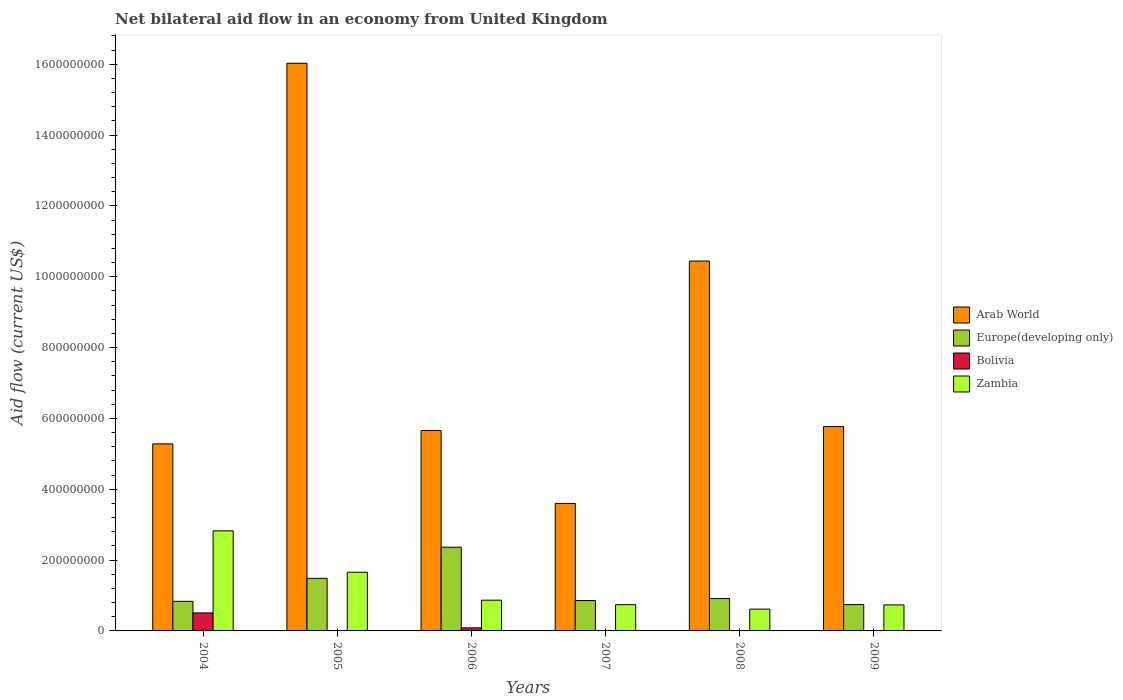How many different coloured bars are there?
Provide a succinct answer. 4. Are the number of bars per tick equal to the number of legend labels?
Ensure brevity in your answer.  No. Are the number of bars on each tick of the X-axis equal?
Give a very brief answer. No. What is the label of the 6th group of bars from the left?
Your answer should be very brief. 2009. In how many cases, is the number of bars for a given year not equal to the number of legend labels?
Ensure brevity in your answer.  2. What is the net bilateral aid flow in Arab World in 2005?
Your answer should be very brief. 1.60e+09. Across all years, what is the maximum net bilateral aid flow in Arab World?
Ensure brevity in your answer.  1.60e+09. Across all years, what is the minimum net bilateral aid flow in Europe(developing only)?
Make the answer very short. 7.44e+07. In which year was the net bilateral aid flow in Europe(developing only) maximum?
Your answer should be compact. 2006. What is the total net bilateral aid flow in Bolivia in the graph?
Offer a terse response. 6.11e+07. What is the difference between the net bilateral aid flow in Zambia in 2005 and that in 2007?
Give a very brief answer. 9.17e+07. What is the difference between the net bilateral aid flow in Europe(developing only) in 2007 and the net bilateral aid flow in Bolivia in 2005?
Your answer should be compact. 8.58e+07. What is the average net bilateral aid flow in Europe(developing only) per year?
Your response must be concise. 1.20e+08. In the year 2006, what is the difference between the net bilateral aid flow in Arab World and net bilateral aid flow in Europe(developing only)?
Offer a terse response. 3.30e+08. In how many years, is the net bilateral aid flow in Arab World greater than 80000000 US$?
Keep it short and to the point. 6. What is the ratio of the net bilateral aid flow in Europe(developing only) in 2005 to that in 2006?
Offer a terse response. 0.63. Is the net bilateral aid flow in Arab World in 2006 less than that in 2007?
Ensure brevity in your answer.  No. What is the difference between the highest and the second highest net bilateral aid flow in Zambia?
Provide a short and direct response. 1.17e+08. What is the difference between the highest and the lowest net bilateral aid flow in Arab World?
Offer a terse response. 1.24e+09. How many bars are there?
Provide a succinct answer. 22. Are the values on the major ticks of Y-axis written in scientific E-notation?
Offer a terse response. No. Does the graph contain any zero values?
Your answer should be very brief. Yes. Where does the legend appear in the graph?
Your response must be concise. Center right. What is the title of the graph?
Your answer should be very brief. Net bilateral aid flow in an economy from United Kingdom. What is the label or title of the X-axis?
Ensure brevity in your answer.  Years. What is the label or title of the Y-axis?
Your answer should be compact. Aid flow (current US$). What is the Aid flow (current US$) in Arab World in 2004?
Offer a very short reply. 5.28e+08. What is the Aid flow (current US$) of Europe(developing only) in 2004?
Offer a very short reply. 8.36e+07. What is the Aid flow (current US$) in Bolivia in 2004?
Your answer should be very brief. 5.08e+07. What is the Aid flow (current US$) of Zambia in 2004?
Your response must be concise. 2.83e+08. What is the Aid flow (current US$) of Arab World in 2005?
Your response must be concise. 1.60e+09. What is the Aid flow (current US$) of Europe(developing only) in 2005?
Offer a very short reply. 1.48e+08. What is the Aid flow (current US$) of Bolivia in 2005?
Ensure brevity in your answer.  0. What is the Aid flow (current US$) in Zambia in 2005?
Your answer should be very brief. 1.66e+08. What is the Aid flow (current US$) in Arab World in 2006?
Offer a terse response. 5.66e+08. What is the Aid flow (current US$) of Europe(developing only) in 2006?
Give a very brief answer. 2.36e+08. What is the Aid flow (current US$) in Bolivia in 2006?
Provide a short and direct response. 8.69e+06. What is the Aid flow (current US$) of Zambia in 2006?
Offer a very short reply. 8.68e+07. What is the Aid flow (current US$) of Arab World in 2007?
Your answer should be very brief. 3.60e+08. What is the Aid flow (current US$) of Europe(developing only) in 2007?
Your answer should be very brief. 8.58e+07. What is the Aid flow (current US$) in Bolivia in 2007?
Your answer should be very brief. 0. What is the Aid flow (current US$) of Zambia in 2007?
Make the answer very short. 7.40e+07. What is the Aid flow (current US$) of Arab World in 2008?
Make the answer very short. 1.04e+09. What is the Aid flow (current US$) in Europe(developing only) in 2008?
Keep it short and to the point. 9.15e+07. What is the Aid flow (current US$) of Bolivia in 2008?
Provide a short and direct response. 1.02e+06. What is the Aid flow (current US$) in Zambia in 2008?
Make the answer very short. 6.16e+07. What is the Aid flow (current US$) of Arab World in 2009?
Your answer should be compact. 5.77e+08. What is the Aid flow (current US$) of Europe(developing only) in 2009?
Ensure brevity in your answer.  7.44e+07. What is the Aid flow (current US$) of Bolivia in 2009?
Offer a terse response. 5.30e+05. What is the Aid flow (current US$) in Zambia in 2009?
Offer a very short reply. 7.35e+07. Across all years, what is the maximum Aid flow (current US$) in Arab World?
Provide a succinct answer. 1.60e+09. Across all years, what is the maximum Aid flow (current US$) in Europe(developing only)?
Offer a very short reply. 2.36e+08. Across all years, what is the maximum Aid flow (current US$) of Bolivia?
Offer a very short reply. 5.08e+07. Across all years, what is the maximum Aid flow (current US$) in Zambia?
Your response must be concise. 2.83e+08. Across all years, what is the minimum Aid flow (current US$) in Arab World?
Your answer should be compact. 3.60e+08. Across all years, what is the minimum Aid flow (current US$) of Europe(developing only)?
Offer a very short reply. 7.44e+07. Across all years, what is the minimum Aid flow (current US$) of Bolivia?
Your response must be concise. 0. Across all years, what is the minimum Aid flow (current US$) of Zambia?
Offer a terse response. 6.16e+07. What is the total Aid flow (current US$) of Arab World in the graph?
Ensure brevity in your answer.  4.68e+09. What is the total Aid flow (current US$) in Europe(developing only) in the graph?
Your answer should be compact. 7.20e+08. What is the total Aid flow (current US$) of Bolivia in the graph?
Keep it short and to the point. 6.11e+07. What is the total Aid flow (current US$) of Zambia in the graph?
Your answer should be compact. 7.44e+08. What is the difference between the Aid flow (current US$) in Arab World in 2004 and that in 2005?
Provide a succinct answer. -1.07e+09. What is the difference between the Aid flow (current US$) of Europe(developing only) in 2004 and that in 2005?
Make the answer very short. -6.49e+07. What is the difference between the Aid flow (current US$) of Zambia in 2004 and that in 2005?
Your answer should be very brief. 1.17e+08. What is the difference between the Aid flow (current US$) in Arab World in 2004 and that in 2006?
Your answer should be very brief. -3.78e+07. What is the difference between the Aid flow (current US$) in Europe(developing only) in 2004 and that in 2006?
Provide a succinct answer. -1.53e+08. What is the difference between the Aid flow (current US$) in Bolivia in 2004 and that in 2006?
Offer a terse response. 4.21e+07. What is the difference between the Aid flow (current US$) of Zambia in 2004 and that in 2006?
Keep it short and to the point. 1.96e+08. What is the difference between the Aid flow (current US$) in Arab World in 2004 and that in 2007?
Your response must be concise. 1.68e+08. What is the difference between the Aid flow (current US$) in Europe(developing only) in 2004 and that in 2007?
Provide a short and direct response. -2.20e+06. What is the difference between the Aid flow (current US$) in Zambia in 2004 and that in 2007?
Your answer should be very brief. 2.09e+08. What is the difference between the Aid flow (current US$) of Arab World in 2004 and that in 2008?
Your answer should be very brief. -5.16e+08. What is the difference between the Aid flow (current US$) of Europe(developing only) in 2004 and that in 2008?
Make the answer very short. -7.99e+06. What is the difference between the Aid flow (current US$) in Bolivia in 2004 and that in 2008?
Provide a short and direct response. 4.98e+07. What is the difference between the Aid flow (current US$) of Zambia in 2004 and that in 2008?
Your response must be concise. 2.21e+08. What is the difference between the Aid flow (current US$) in Arab World in 2004 and that in 2009?
Provide a short and direct response. -4.89e+07. What is the difference between the Aid flow (current US$) in Europe(developing only) in 2004 and that in 2009?
Give a very brief answer. 9.19e+06. What is the difference between the Aid flow (current US$) in Bolivia in 2004 and that in 2009?
Offer a very short reply. 5.03e+07. What is the difference between the Aid flow (current US$) of Zambia in 2004 and that in 2009?
Offer a terse response. 2.09e+08. What is the difference between the Aid flow (current US$) in Arab World in 2005 and that in 2006?
Your answer should be compact. 1.04e+09. What is the difference between the Aid flow (current US$) in Europe(developing only) in 2005 and that in 2006?
Keep it short and to the point. -8.79e+07. What is the difference between the Aid flow (current US$) in Zambia in 2005 and that in 2006?
Provide a short and direct response. 7.90e+07. What is the difference between the Aid flow (current US$) of Arab World in 2005 and that in 2007?
Provide a short and direct response. 1.24e+09. What is the difference between the Aid flow (current US$) in Europe(developing only) in 2005 and that in 2007?
Offer a terse response. 6.27e+07. What is the difference between the Aid flow (current US$) in Zambia in 2005 and that in 2007?
Provide a succinct answer. 9.17e+07. What is the difference between the Aid flow (current US$) of Arab World in 2005 and that in 2008?
Keep it short and to the point. 5.58e+08. What is the difference between the Aid flow (current US$) of Europe(developing only) in 2005 and that in 2008?
Provide a succinct answer. 5.69e+07. What is the difference between the Aid flow (current US$) of Zambia in 2005 and that in 2008?
Make the answer very short. 1.04e+08. What is the difference between the Aid flow (current US$) in Arab World in 2005 and that in 2009?
Ensure brevity in your answer.  1.03e+09. What is the difference between the Aid flow (current US$) in Europe(developing only) in 2005 and that in 2009?
Offer a very short reply. 7.41e+07. What is the difference between the Aid flow (current US$) in Zambia in 2005 and that in 2009?
Your response must be concise. 9.22e+07. What is the difference between the Aid flow (current US$) in Arab World in 2006 and that in 2007?
Keep it short and to the point. 2.06e+08. What is the difference between the Aid flow (current US$) of Europe(developing only) in 2006 and that in 2007?
Offer a terse response. 1.51e+08. What is the difference between the Aid flow (current US$) in Zambia in 2006 and that in 2007?
Ensure brevity in your answer.  1.28e+07. What is the difference between the Aid flow (current US$) of Arab World in 2006 and that in 2008?
Your answer should be compact. -4.78e+08. What is the difference between the Aid flow (current US$) in Europe(developing only) in 2006 and that in 2008?
Make the answer very short. 1.45e+08. What is the difference between the Aid flow (current US$) of Bolivia in 2006 and that in 2008?
Your answer should be compact. 7.67e+06. What is the difference between the Aid flow (current US$) of Zambia in 2006 and that in 2008?
Provide a succinct answer. 2.52e+07. What is the difference between the Aid flow (current US$) of Arab World in 2006 and that in 2009?
Offer a very short reply. -1.11e+07. What is the difference between the Aid flow (current US$) in Europe(developing only) in 2006 and that in 2009?
Your answer should be very brief. 1.62e+08. What is the difference between the Aid flow (current US$) in Bolivia in 2006 and that in 2009?
Your answer should be compact. 8.16e+06. What is the difference between the Aid flow (current US$) in Zambia in 2006 and that in 2009?
Give a very brief answer. 1.32e+07. What is the difference between the Aid flow (current US$) of Arab World in 2007 and that in 2008?
Your answer should be compact. -6.84e+08. What is the difference between the Aid flow (current US$) of Europe(developing only) in 2007 and that in 2008?
Ensure brevity in your answer.  -5.79e+06. What is the difference between the Aid flow (current US$) of Zambia in 2007 and that in 2008?
Offer a terse response. 1.25e+07. What is the difference between the Aid flow (current US$) of Arab World in 2007 and that in 2009?
Ensure brevity in your answer.  -2.17e+08. What is the difference between the Aid flow (current US$) of Europe(developing only) in 2007 and that in 2009?
Provide a short and direct response. 1.14e+07. What is the difference between the Aid flow (current US$) in Arab World in 2008 and that in 2009?
Provide a short and direct response. 4.67e+08. What is the difference between the Aid flow (current US$) of Europe(developing only) in 2008 and that in 2009?
Provide a succinct answer. 1.72e+07. What is the difference between the Aid flow (current US$) in Bolivia in 2008 and that in 2009?
Offer a terse response. 4.90e+05. What is the difference between the Aid flow (current US$) of Zambia in 2008 and that in 2009?
Give a very brief answer. -1.20e+07. What is the difference between the Aid flow (current US$) of Arab World in 2004 and the Aid flow (current US$) of Europe(developing only) in 2005?
Provide a succinct answer. 3.80e+08. What is the difference between the Aid flow (current US$) of Arab World in 2004 and the Aid flow (current US$) of Zambia in 2005?
Provide a short and direct response. 3.62e+08. What is the difference between the Aid flow (current US$) of Europe(developing only) in 2004 and the Aid flow (current US$) of Zambia in 2005?
Provide a succinct answer. -8.22e+07. What is the difference between the Aid flow (current US$) of Bolivia in 2004 and the Aid flow (current US$) of Zambia in 2005?
Ensure brevity in your answer.  -1.15e+08. What is the difference between the Aid flow (current US$) of Arab World in 2004 and the Aid flow (current US$) of Europe(developing only) in 2006?
Keep it short and to the point. 2.92e+08. What is the difference between the Aid flow (current US$) in Arab World in 2004 and the Aid flow (current US$) in Bolivia in 2006?
Give a very brief answer. 5.19e+08. What is the difference between the Aid flow (current US$) of Arab World in 2004 and the Aid flow (current US$) of Zambia in 2006?
Ensure brevity in your answer.  4.41e+08. What is the difference between the Aid flow (current US$) in Europe(developing only) in 2004 and the Aid flow (current US$) in Bolivia in 2006?
Offer a very short reply. 7.49e+07. What is the difference between the Aid flow (current US$) of Europe(developing only) in 2004 and the Aid flow (current US$) of Zambia in 2006?
Your response must be concise. -3.22e+06. What is the difference between the Aid flow (current US$) of Bolivia in 2004 and the Aid flow (current US$) of Zambia in 2006?
Offer a very short reply. -3.59e+07. What is the difference between the Aid flow (current US$) in Arab World in 2004 and the Aid flow (current US$) in Europe(developing only) in 2007?
Make the answer very short. 4.42e+08. What is the difference between the Aid flow (current US$) of Arab World in 2004 and the Aid flow (current US$) of Zambia in 2007?
Ensure brevity in your answer.  4.54e+08. What is the difference between the Aid flow (current US$) in Europe(developing only) in 2004 and the Aid flow (current US$) in Zambia in 2007?
Your answer should be compact. 9.53e+06. What is the difference between the Aid flow (current US$) in Bolivia in 2004 and the Aid flow (current US$) in Zambia in 2007?
Your response must be concise. -2.32e+07. What is the difference between the Aid flow (current US$) of Arab World in 2004 and the Aid flow (current US$) of Europe(developing only) in 2008?
Ensure brevity in your answer.  4.36e+08. What is the difference between the Aid flow (current US$) of Arab World in 2004 and the Aid flow (current US$) of Bolivia in 2008?
Keep it short and to the point. 5.27e+08. What is the difference between the Aid flow (current US$) of Arab World in 2004 and the Aid flow (current US$) of Zambia in 2008?
Ensure brevity in your answer.  4.66e+08. What is the difference between the Aid flow (current US$) in Europe(developing only) in 2004 and the Aid flow (current US$) in Bolivia in 2008?
Keep it short and to the point. 8.25e+07. What is the difference between the Aid flow (current US$) of Europe(developing only) in 2004 and the Aid flow (current US$) of Zambia in 2008?
Keep it short and to the point. 2.20e+07. What is the difference between the Aid flow (current US$) of Bolivia in 2004 and the Aid flow (current US$) of Zambia in 2008?
Provide a short and direct response. -1.07e+07. What is the difference between the Aid flow (current US$) of Arab World in 2004 and the Aid flow (current US$) of Europe(developing only) in 2009?
Give a very brief answer. 4.54e+08. What is the difference between the Aid flow (current US$) in Arab World in 2004 and the Aid flow (current US$) in Bolivia in 2009?
Your answer should be very brief. 5.27e+08. What is the difference between the Aid flow (current US$) of Arab World in 2004 and the Aid flow (current US$) of Zambia in 2009?
Provide a succinct answer. 4.54e+08. What is the difference between the Aid flow (current US$) of Europe(developing only) in 2004 and the Aid flow (current US$) of Bolivia in 2009?
Provide a succinct answer. 8.30e+07. What is the difference between the Aid flow (current US$) of Europe(developing only) in 2004 and the Aid flow (current US$) of Zambia in 2009?
Provide a short and direct response. 1.00e+07. What is the difference between the Aid flow (current US$) of Bolivia in 2004 and the Aid flow (current US$) of Zambia in 2009?
Your answer should be very brief. -2.27e+07. What is the difference between the Aid flow (current US$) of Arab World in 2005 and the Aid flow (current US$) of Europe(developing only) in 2006?
Offer a terse response. 1.37e+09. What is the difference between the Aid flow (current US$) in Arab World in 2005 and the Aid flow (current US$) in Bolivia in 2006?
Your answer should be compact. 1.59e+09. What is the difference between the Aid flow (current US$) of Arab World in 2005 and the Aid flow (current US$) of Zambia in 2006?
Offer a terse response. 1.52e+09. What is the difference between the Aid flow (current US$) of Europe(developing only) in 2005 and the Aid flow (current US$) of Bolivia in 2006?
Provide a short and direct response. 1.40e+08. What is the difference between the Aid flow (current US$) of Europe(developing only) in 2005 and the Aid flow (current US$) of Zambia in 2006?
Your answer should be compact. 6.17e+07. What is the difference between the Aid flow (current US$) of Arab World in 2005 and the Aid flow (current US$) of Europe(developing only) in 2007?
Offer a terse response. 1.52e+09. What is the difference between the Aid flow (current US$) in Arab World in 2005 and the Aid flow (current US$) in Zambia in 2007?
Keep it short and to the point. 1.53e+09. What is the difference between the Aid flow (current US$) of Europe(developing only) in 2005 and the Aid flow (current US$) of Zambia in 2007?
Provide a short and direct response. 7.44e+07. What is the difference between the Aid flow (current US$) in Arab World in 2005 and the Aid flow (current US$) in Europe(developing only) in 2008?
Offer a very short reply. 1.51e+09. What is the difference between the Aid flow (current US$) of Arab World in 2005 and the Aid flow (current US$) of Bolivia in 2008?
Provide a short and direct response. 1.60e+09. What is the difference between the Aid flow (current US$) in Arab World in 2005 and the Aid flow (current US$) in Zambia in 2008?
Your answer should be compact. 1.54e+09. What is the difference between the Aid flow (current US$) of Europe(developing only) in 2005 and the Aid flow (current US$) of Bolivia in 2008?
Provide a succinct answer. 1.47e+08. What is the difference between the Aid flow (current US$) of Europe(developing only) in 2005 and the Aid flow (current US$) of Zambia in 2008?
Provide a short and direct response. 8.69e+07. What is the difference between the Aid flow (current US$) of Arab World in 2005 and the Aid flow (current US$) of Europe(developing only) in 2009?
Make the answer very short. 1.53e+09. What is the difference between the Aid flow (current US$) in Arab World in 2005 and the Aid flow (current US$) in Bolivia in 2009?
Give a very brief answer. 1.60e+09. What is the difference between the Aid flow (current US$) in Arab World in 2005 and the Aid flow (current US$) in Zambia in 2009?
Provide a succinct answer. 1.53e+09. What is the difference between the Aid flow (current US$) of Europe(developing only) in 2005 and the Aid flow (current US$) of Bolivia in 2009?
Provide a succinct answer. 1.48e+08. What is the difference between the Aid flow (current US$) of Europe(developing only) in 2005 and the Aid flow (current US$) of Zambia in 2009?
Provide a succinct answer. 7.49e+07. What is the difference between the Aid flow (current US$) of Arab World in 2006 and the Aid flow (current US$) of Europe(developing only) in 2007?
Your response must be concise. 4.80e+08. What is the difference between the Aid flow (current US$) of Arab World in 2006 and the Aid flow (current US$) of Zambia in 2007?
Your response must be concise. 4.92e+08. What is the difference between the Aid flow (current US$) in Europe(developing only) in 2006 and the Aid flow (current US$) in Zambia in 2007?
Provide a succinct answer. 1.62e+08. What is the difference between the Aid flow (current US$) of Bolivia in 2006 and the Aid flow (current US$) of Zambia in 2007?
Offer a very short reply. -6.53e+07. What is the difference between the Aid flow (current US$) of Arab World in 2006 and the Aid flow (current US$) of Europe(developing only) in 2008?
Give a very brief answer. 4.74e+08. What is the difference between the Aid flow (current US$) of Arab World in 2006 and the Aid flow (current US$) of Bolivia in 2008?
Ensure brevity in your answer.  5.65e+08. What is the difference between the Aid flow (current US$) in Arab World in 2006 and the Aid flow (current US$) in Zambia in 2008?
Your answer should be compact. 5.04e+08. What is the difference between the Aid flow (current US$) in Europe(developing only) in 2006 and the Aid flow (current US$) in Bolivia in 2008?
Provide a succinct answer. 2.35e+08. What is the difference between the Aid flow (current US$) in Europe(developing only) in 2006 and the Aid flow (current US$) in Zambia in 2008?
Provide a short and direct response. 1.75e+08. What is the difference between the Aid flow (current US$) of Bolivia in 2006 and the Aid flow (current US$) of Zambia in 2008?
Keep it short and to the point. -5.29e+07. What is the difference between the Aid flow (current US$) of Arab World in 2006 and the Aid flow (current US$) of Europe(developing only) in 2009?
Make the answer very short. 4.91e+08. What is the difference between the Aid flow (current US$) in Arab World in 2006 and the Aid flow (current US$) in Bolivia in 2009?
Keep it short and to the point. 5.65e+08. What is the difference between the Aid flow (current US$) in Arab World in 2006 and the Aid flow (current US$) in Zambia in 2009?
Give a very brief answer. 4.92e+08. What is the difference between the Aid flow (current US$) of Europe(developing only) in 2006 and the Aid flow (current US$) of Bolivia in 2009?
Keep it short and to the point. 2.36e+08. What is the difference between the Aid flow (current US$) in Europe(developing only) in 2006 and the Aid flow (current US$) in Zambia in 2009?
Your response must be concise. 1.63e+08. What is the difference between the Aid flow (current US$) in Bolivia in 2006 and the Aid flow (current US$) in Zambia in 2009?
Ensure brevity in your answer.  -6.48e+07. What is the difference between the Aid flow (current US$) of Arab World in 2007 and the Aid flow (current US$) of Europe(developing only) in 2008?
Offer a terse response. 2.68e+08. What is the difference between the Aid flow (current US$) of Arab World in 2007 and the Aid flow (current US$) of Bolivia in 2008?
Provide a short and direct response. 3.59e+08. What is the difference between the Aid flow (current US$) in Arab World in 2007 and the Aid flow (current US$) in Zambia in 2008?
Your response must be concise. 2.98e+08. What is the difference between the Aid flow (current US$) of Europe(developing only) in 2007 and the Aid flow (current US$) of Bolivia in 2008?
Provide a short and direct response. 8.47e+07. What is the difference between the Aid flow (current US$) in Europe(developing only) in 2007 and the Aid flow (current US$) in Zambia in 2008?
Provide a succinct answer. 2.42e+07. What is the difference between the Aid flow (current US$) of Arab World in 2007 and the Aid flow (current US$) of Europe(developing only) in 2009?
Keep it short and to the point. 2.86e+08. What is the difference between the Aid flow (current US$) in Arab World in 2007 and the Aid flow (current US$) in Bolivia in 2009?
Offer a terse response. 3.59e+08. What is the difference between the Aid flow (current US$) of Arab World in 2007 and the Aid flow (current US$) of Zambia in 2009?
Your answer should be very brief. 2.86e+08. What is the difference between the Aid flow (current US$) in Europe(developing only) in 2007 and the Aid flow (current US$) in Bolivia in 2009?
Your response must be concise. 8.52e+07. What is the difference between the Aid flow (current US$) in Europe(developing only) in 2007 and the Aid flow (current US$) in Zambia in 2009?
Provide a short and direct response. 1.22e+07. What is the difference between the Aid flow (current US$) in Arab World in 2008 and the Aid flow (current US$) in Europe(developing only) in 2009?
Keep it short and to the point. 9.70e+08. What is the difference between the Aid flow (current US$) of Arab World in 2008 and the Aid flow (current US$) of Bolivia in 2009?
Your response must be concise. 1.04e+09. What is the difference between the Aid flow (current US$) in Arab World in 2008 and the Aid flow (current US$) in Zambia in 2009?
Provide a succinct answer. 9.71e+08. What is the difference between the Aid flow (current US$) of Europe(developing only) in 2008 and the Aid flow (current US$) of Bolivia in 2009?
Offer a very short reply. 9.10e+07. What is the difference between the Aid flow (current US$) of Europe(developing only) in 2008 and the Aid flow (current US$) of Zambia in 2009?
Provide a succinct answer. 1.80e+07. What is the difference between the Aid flow (current US$) in Bolivia in 2008 and the Aid flow (current US$) in Zambia in 2009?
Give a very brief answer. -7.25e+07. What is the average Aid flow (current US$) in Arab World per year?
Provide a succinct answer. 7.80e+08. What is the average Aid flow (current US$) in Europe(developing only) per year?
Your answer should be very brief. 1.20e+08. What is the average Aid flow (current US$) of Bolivia per year?
Ensure brevity in your answer.  1.02e+07. What is the average Aid flow (current US$) in Zambia per year?
Your answer should be compact. 1.24e+08. In the year 2004, what is the difference between the Aid flow (current US$) in Arab World and Aid flow (current US$) in Europe(developing only)?
Offer a very short reply. 4.44e+08. In the year 2004, what is the difference between the Aid flow (current US$) in Arab World and Aid flow (current US$) in Bolivia?
Provide a succinct answer. 4.77e+08. In the year 2004, what is the difference between the Aid flow (current US$) of Arab World and Aid flow (current US$) of Zambia?
Keep it short and to the point. 2.45e+08. In the year 2004, what is the difference between the Aid flow (current US$) of Europe(developing only) and Aid flow (current US$) of Bolivia?
Provide a succinct answer. 3.27e+07. In the year 2004, what is the difference between the Aid flow (current US$) in Europe(developing only) and Aid flow (current US$) in Zambia?
Ensure brevity in your answer.  -1.99e+08. In the year 2004, what is the difference between the Aid flow (current US$) in Bolivia and Aid flow (current US$) in Zambia?
Your response must be concise. -2.32e+08. In the year 2005, what is the difference between the Aid flow (current US$) in Arab World and Aid flow (current US$) in Europe(developing only)?
Your response must be concise. 1.45e+09. In the year 2005, what is the difference between the Aid flow (current US$) of Arab World and Aid flow (current US$) of Zambia?
Ensure brevity in your answer.  1.44e+09. In the year 2005, what is the difference between the Aid flow (current US$) of Europe(developing only) and Aid flow (current US$) of Zambia?
Your answer should be compact. -1.73e+07. In the year 2006, what is the difference between the Aid flow (current US$) of Arab World and Aid flow (current US$) of Europe(developing only)?
Your answer should be compact. 3.30e+08. In the year 2006, what is the difference between the Aid flow (current US$) of Arab World and Aid flow (current US$) of Bolivia?
Give a very brief answer. 5.57e+08. In the year 2006, what is the difference between the Aid flow (current US$) of Arab World and Aid flow (current US$) of Zambia?
Provide a short and direct response. 4.79e+08. In the year 2006, what is the difference between the Aid flow (current US$) of Europe(developing only) and Aid flow (current US$) of Bolivia?
Offer a terse response. 2.28e+08. In the year 2006, what is the difference between the Aid flow (current US$) in Europe(developing only) and Aid flow (current US$) in Zambia?
Give a very brief answer. 1.50e+08. In the year 2006, what is the difference between the Aid flow (current US$) of Bolivia and Aid flow (current US$) of Zambia?
Your response must be concise. -7.81e+07. In the year 2007, what is the difference between the Aid flow (current US$) of Arab World and Aid flow (current US$) of Europe(developing only)?
Offer a very short reply. 2.74e+08. In the year 2007, what is the difference between the Aid flow (current US$) in Arab World and Aid flow (current US$) in Zambia?
Make the answer very short. 2.86e+08. In the year 2007, what is the difference between the Aid flow (current US$) of Europe(developing only) and Aid flow (current US$) of Zambia?
Your answer should be very brief. 1.17e+07. In the year 2008, what is the difference between the Aid flow (current US$) in Arab World and Aid flow (current US$) in Europe(developing only)?
Provide a succinct answer. 9.53e+08. In the year 2008, what is the difference between the Aid flow (current US$) in Arab World and Aid flow (current US$) in Bolivia?
Your response must be concise. 1.04e+09. In the year 2008, what is the difference between the Aid flow (current US$) of Arab World and Aid flow (current US$) of Zambia?
Offer a very short reply. 9.83e+08. In the year 2008, what is the difference between the Aid flow (current US$) in Europe(developing only) and Aid flow (current US$) in Bolivia?
Your answer should be compact. 9.05e+07. In the year 2008, what is the difference between the Aid flow (current US$) of Europe(developing only) and Aid flow (current US$) of Zambia?
Ensure brevity in your answer.  3.00e+07. In the year 2008, what is the difference between the Aid flow (current US$) of Bolivia and Aid flow (current US$) of Zambia?
Your answer should be very brief. -6.05e+07. In the year 2009, what is the difference between the Aid flow (current US$) in Arab World and Aid flow (current US$) in Europe(developing only)?
Offer a very short reply. 5.03e+08. In the year 2009, what is the difference between the Aid flow (current US$) in Arab World and Aid flow (current US$) in Bolivia?
Offer a terse response. 5.76e+08. In the year 2009, what is the difference between the Aid flow (current US$) in Arab World and Aid flow (current US$) in Zambia?
Offer a terse response. 5.03e+08. In the year 2009, what is the difference between the Aid flow (current US$) in Europe(developing only) and Aid flow (current US$) in Bolivia?
Provide a succinct answer. 7.38e+07. In the year 2009, what is the difference between the Aid flow (current US$) in Europe(developing only) and Aid flow (current US$) in Zambia?
Your answer should be compact. 8.30e+05. In the year 2009, what is the difference between the Aid flow (current US$) of Bolivia and Aid flow (current US$) of Zambia?
Make the answer very short. -7.30e+07. What is the ratio of the Aid flow (current US$) of Arab World in 2004 to that in 2005?
Your answer should be compact. 0.33. What is the ratio of the Aid flow (current US$) of Europe(developing only) in 2004 to that in 2005?
Provide a succinct answer. 0.56. What is the ratio of the Aid flow (current US$) of Zambia in 2004 to that in 2005?
Your answer should be compact. 1.7. What is the ratio of the Aid flow (current US$) of Arab World in 2004 to that in 2006?
Provide a succinct answer. 0.93. What is the ratio of the Aid flow (current US$) of Europe(developing only) in 2004 to that in 2006?
Offer a very short reply. 0.35. What is the ratio of the Aid flow (current US$) of Bolivia in 2004 to that in 2006?
Provide a short and direct response. 5.85. What is the ratio of the Aid flow (current US$) of Zambia in 2004 to that in 2006?
Your response must be concise. 3.26. What is the ratio of the Aid flow (current US$) of Arab World in 2004 to that in 2007?
Offer a terse response. 1.47. What is the ratio of the Aid flow (current US$) in Europe(developing only) in 2004 to that in 2007?
Your response must be concise. 0.97. What is the ratio of the Aid flow (current US$) of Zambia in 2004 to that in 2007?
Your response must be concise. 3.82. What is the ratio of the Aid flow (current US$) in Arab World in 2004 to that in 2008?
Provide a succinct answer. 0.51. What is the ratio of the Aid flow (current US$) in Europe(developing only) in 2004 to that in 2008?
Offer a very short reply. 0.91. What is the ratio of the Aid flow (current US$) in Bolivia in 2004 to that in 2008?
Provide a short and direct response. 49.83. What is the ratio of the Aid flow (current US$) of Zambia in 2004 to that in 2008?
Your response must be concise. 4.59. What is the ratio of the Aid flow (current US$) of Arab World in 2004 to that in 2009?
Offer a very short reply. 0.92. What is the ratio of the Aid flow (current US$) of Europe(developing only) in 2004 to that in 2009?
Your answer should be compact. 1.12. What is the ratio of the Aid flow (current US$) of Bolivia in 2004 to that in 2009?
Your answer should be very brief. 95.91. What is the ratio of the Aid flow (current US$) of Zambia in 2004 to that in 2009?
Your response must be concise. 3.84. What is the ratio of the Aid flow (current US$) of Arab World in 2005 to that in 2006?
Keep it short and to the point. 2.83. What is the ratio of the Aid flow (current US$) of Europe(developing only) in 2005 to that in 2006?
Ensure brevity in your answer.  0.63. What is the ratio of the Aid flow (current US$) of Zambia in 2005 to that in 2006?
Offer a terse response. 1.91. What is the ratio of the Aid flow (current US$) of Arab World in 2005 to that in 2007?
Make the answer very short. 4.45. What is the ratio of the Aid flow (current US$) in Europe(developing only) in 2005 to that in 2007?
Your answer should be compact. 1.73. What is the ratio of the Aid flow (current US$) of Zambia in 2005 to that in 2007?
Provide a short and direct response. 2.24. What is the ratio of the Aid flow (current US$) in Arab World in 2005 to that in 2008?
Keep it short and to the point. 1.53. What is the ratio of the Aid flow (current US$) in Europe(developing only) in 2005 to that in 2008?
Keep it short and to the point. 1.62. What is the ratio of the Aid flow (current US$) of Zambia in 2005 to that in 2008?
Offer a very short reply. 2.69. What is the ratio of the Aid flow (current US$) in Arab World in 2005 to that in 2009?
Make the answer very short. 2.78. What is the ratio of the Aid flow (current US$) of Europe(developing only) in 2005 to that in 2009?
Provide a succinct answer. 2. What is the ratio of the Aid flow (current US$) of Zambia in 2005 to that in 2009?
Give a very brief answer. 2.25. What is the ratio of the Aid flow (current US$) of Arab World in 2006 to that in 2007?
Provide a short and direct response. 1.57. What is the ratio of the Aid flow (current US$) in Europe(developing only) in 2006 to that in 2007?
Keep it short and to the point. 2.76. What is the ratio of the Aid flow (current US$) in Zambia in 2006 to that in 2007?
Your response must be concise. 1.17. What is the ratio of the Aid flow (current US$) of Arab World in 2006 to that in 2008?
Keep it short and to the point. 0.54. What is the ratio of the Aid flow (current US$) in Europe(developing only) in 2006 to that in 2008?
Your answer should be compact. 2.58. What is the ratio of the Aid flow (current US$) in Bolivia in 2006 to that in 2008?
Ensure brevity in your answer.  8.52. What is the ratio of the Aid flow (current US$) in Zambia in 2006 to that in 2008?
Your response must be concise. 1.41. What is the ratio of the Aid flow (current US$) in Arab World in 2006 to that in 2009?
Ensure brevity in your answer.  0.98. What is the ratio of the Aid flow (current US$) in Europe(developing only) in 2006 to that in 2009?
Make the answer very short. 3.18. What is the ratio of the Aid flow (current US$) of Bolivia in 2006 to that in 2009?
Your answer should be compact. 16.4. What is the ratio of the Aid flow (current US$) in Zambia in 2006 to that in 2009?
Give a very brief answer. 1.18. What is the ratio of the Aid flow (current US$) in Arab World in 2007 to that in 2008?
Your response must be concise. 0.34. What is the ratio of the Aid flow (current US$) in Europe(developing only) in 2007 to that in 2008?
Your answer should be very brief. 0.94. What is the ratio of the Aid flow (current US$) in Zambia in 2007 to that in 2008?
Make the answer very short. 1.2. What is the ratio of the Aid flow (current US$) in Arab World in 2007 to that in 2009?
Keep it short and to the point. 0.62. What is the ratio of the Aid flow (current US$) in Europe(developing only) in 2007 to that in 2009?
Provide a succinct answer. 1.15. What is the ratio of the Aid flow (current US$) in Zambia in 2007 to that in 2009?
Make the answer very short. 1.01. What is the ratio of the Aid flow (current US$) of Arab World in 2008 to that in 2009?
Offer a very short reply. 1.81. What is the ratio of the Aid flow (current US$) in Europe(developing only) in 2008 to that in 2009?
Keep it short and to the point. 1.23. What is the ratio of the Aid flow (current US$) of Bolivia in 2008 to that in 2009?
Give a very brief answer. 1.92. What is the ratio of the Aid flow (current US$) of Zambia in 2008 to that in 2009?
Provide a succinct answer. 0.84. What is the difference between the highest and the second highest Aid flow (current US$) in Arab World?
Make the answer very short. 5.58e+08. What is the difference between the highest and the second highest Aid flow (current US$) of Europe(developing only)?
Make the answer very short. 8.79e+07. What is the difference between the highest and the second highest Aid flow (current US$) in Bolivia?
Ensure brevity in your answer.  4.21e+07. What is the difference between the highest and the second highest Aid flow (current US$) in Zambia?
Your answer should be compact. 1.17e+08. What is the difference between the highest and the lowest Aid flow (current US$) in Arab World?
Your response must be concise. 1.24e+09. What is the difference between the highest and the lowest Aid flow (current US$) in Europe(developing only)?
Offer a terse response. 1.62e+08. What is the difference between the highest and the lowest Aid flow (current US$) of Bolivia?
Offer a terse response. 5.08e+07. What is the difference between the highest and the lowest Aid flow (current US$) of Zambia?
Provide a short and direct response. 2.21e+08. 